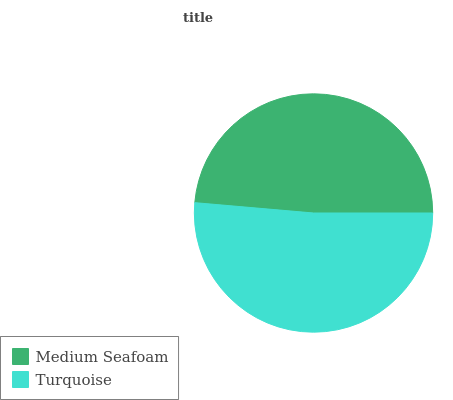Is Medium Seafoam the minimum?
Answer yes or no. Yes. Is Turquoise the maximum?
Answer yes or no. Yes. Is Turquoise the minimum?
Answer yes or no. No. Is Turquoise greater than Medium Seafoam?
Answer yes or no. Yes. Is Medium Seafoam less than Turquoise?
Answer yes or no. Yes. Is Medium Seafoam greater than Turquoise?
Answer yes or no. No. Is Turquoise less than Medium Seafoam?
Answer yes or no. No. Is Turquoise the high median?
Answer yes or no. Yes. Is Medium Seafoam the low median?
Answer yes or no. Yes. Is Medium Seafoam the high median?
Answer yes or no. No. Is Turquoise the low median?
Answer yes or no. No. 